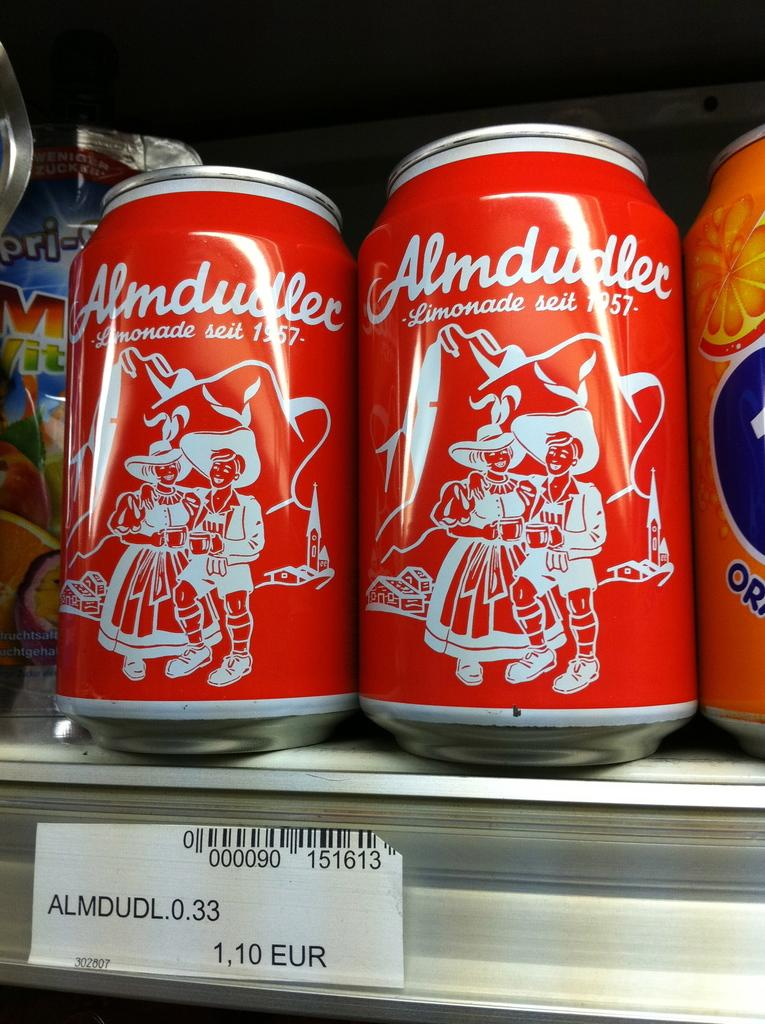<image>
Share a concise interpretation of the image provided. a red aluminum can of Almdudl costs 1.10 Euro 